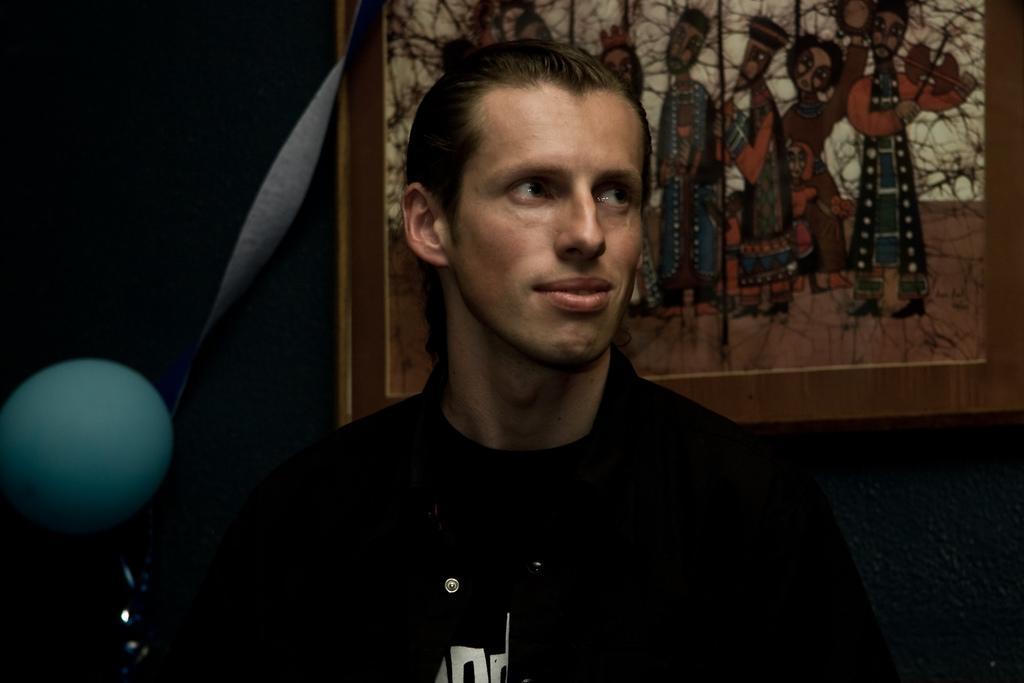Can you describe this image briefly? In the foreground of this picture, there is a man and behind him, there is a photo frame to the wall and there is also a green balloon. 